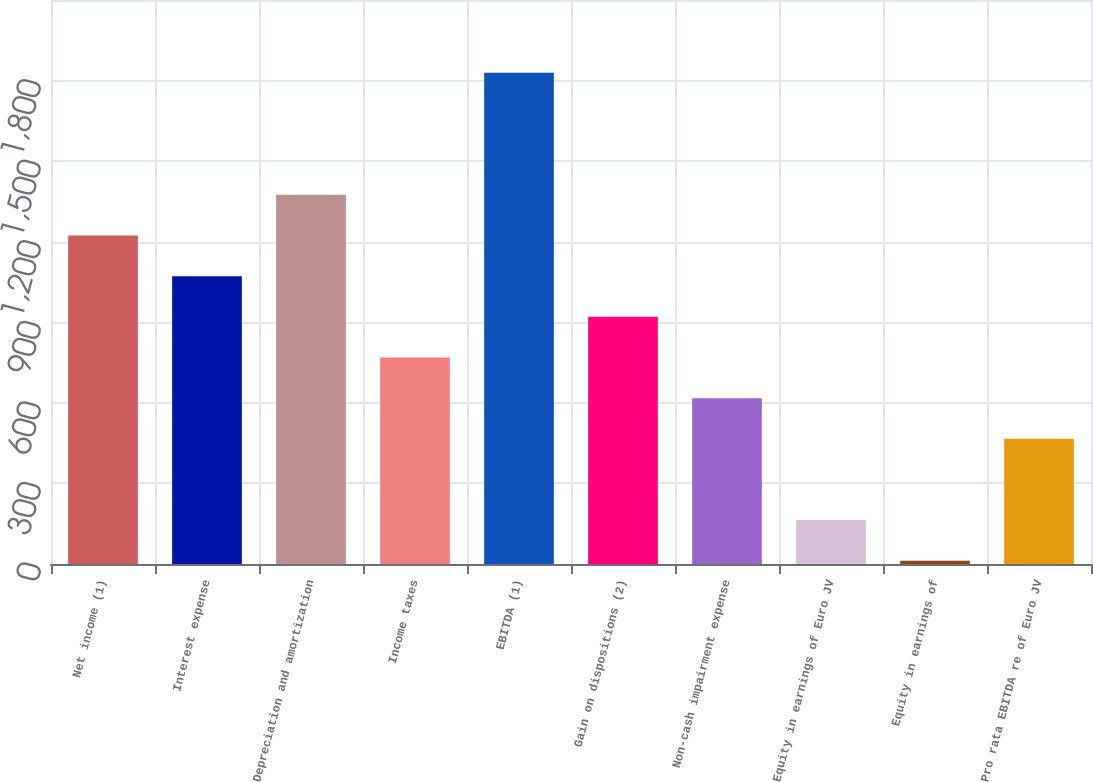<chart> <loc_0><loc_0><loc_500><loc_500><bar_chart><fcel>Net income (1)<fcel>Interest expense<fcel>Depreciation and amortization<fcel>Income taxes<fcel>EBITDA (1)<fcel>Gain on dispositions (2)<fcel>Non-cash impairment expense<fcel>Equity in earnings of Euro JV<fcel>Equity in earnings of<fcel>Pro rata EBITDA re of Euro JV<nl><fcel>1223.2<fcel>1071.8<fcel>1374.6<fcel>769<fcel>1828.8<fcel>920.4<fcel>617.6<fcel>163.4<fcel>12<fcel>466.2<nl></chart> 